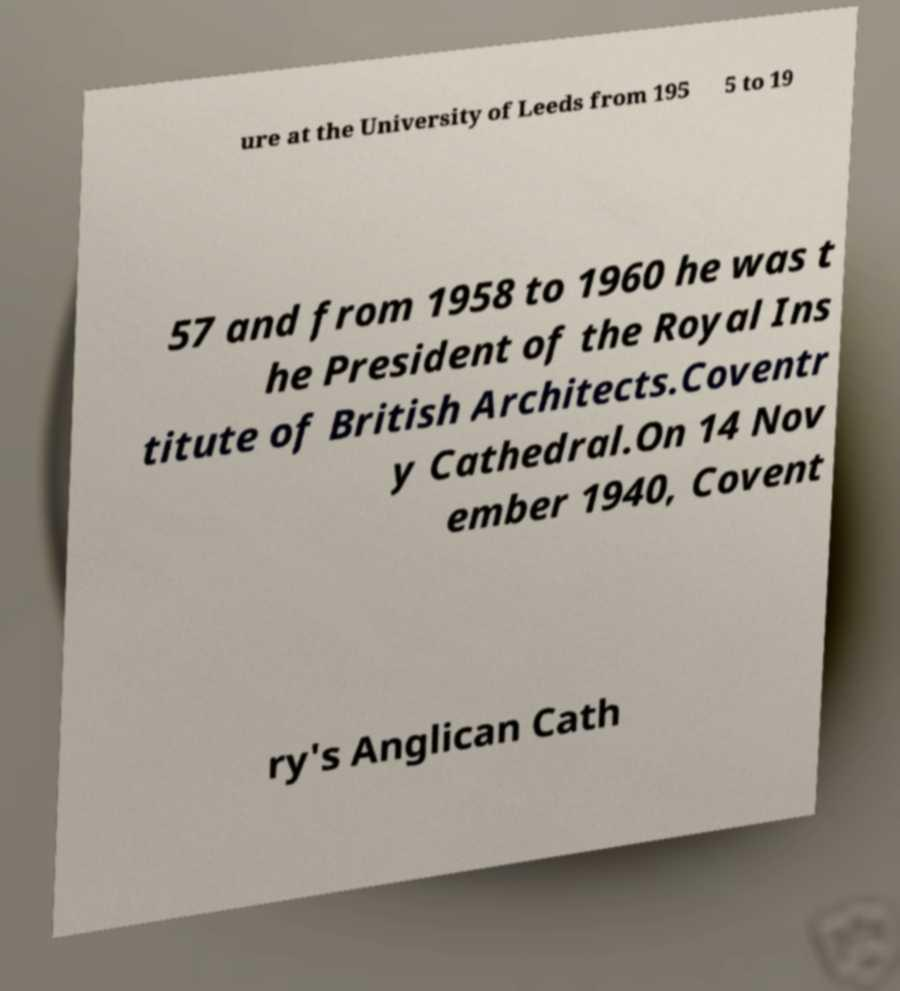Can you read and provide the text displayed in the image?This photo seems to have some interesting text. Can you extract and type it out for me? ure at the University of Leeds from 195 5 to 19 57 and from 1958 to 1960 he was t he President of the Royal Ins titute of British Architects.Coventr y Cathedral.On 14 Nov ember 1940, Covent ry's Anglican Cath 